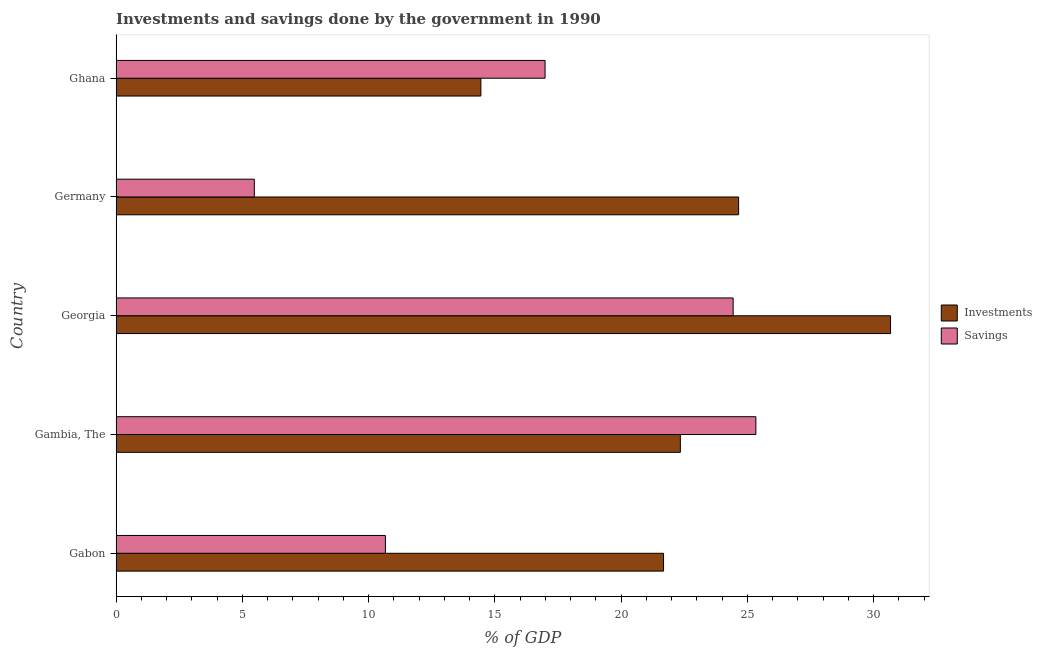How many groups of bars are there?
Provide a short and direct response. 5. Are the number of bars per tick equal to the number of legend labels?
Make the answer very short. Yes. How many bars are there on the 5th tick from the top?
Provide a succinct answer. 2. What is the label of the 2nd group of bars from the top?
Offer a very short reply. Germany. What is the savings of government in Germany?
Your answer should be compact. 5.47. Across all countries, what is the maximum investments of government?
Provide a short and direct response. 30.67. Across all countries, what is the minimum savings of government?
Offer a terse response. 5.47. In which country was the investments of government maximum?
Your answer should be very brief. Georgia. In which country was the savings of government minimum?
Offer a very short reply. Germany. What is the total savings of government in the graph?
Offer a very short reply. 82.89. What is the difference between the savings of government in Gambia, The and that in Georgia?
Provide a short and direct response. 0.9. What is the difference between the investments of government in Ghana and the savings of government in Germany?
Provide a succinct answer. 8.97. What is the average investments of government per country?
Make the answer very short. 22.76. What is the difference between the savings of government and investments of government in Gambia, The?
Offer a terse response. 2.99. In how many countries, is the savings of government greater than 30 %?
Your response must be concise. 0. What is the ratio of the investments of government in Gabon to that in Georgia?
Give a very brief answer. 0.71. Is the investments of government in Gambia, The less than that in Ghana?
Your response must be concise. No. What is the difference between the highest and the second highest investments of government?
Provide a succinct answer. 6.02. What is the difference between the highest and the lowest savings of government?
Give a very brief answer. 19.86. What does the 2nd bar from the top in Ghana represents?
Make the answer very short. Investments. What does the 1st bar from the bottom in Ghana represents?
Your answer should be very brief. Investments. What is the difference between two consecutive major ticks on the X-axis?
Ensure brevity in your answer.  5. Where does the legend appear in the graph?
Your answer should be compact. Center right. What is the title of the graph?
Ensure brevity in your answer.  Investments and savings done by the government in 1990. What is the label or title of the X-axis?
Your answer should be compact. % of GDP. What is the % of GDP of Investments in Gabon?
Offer a very short reply. 21.68. What is the % of GDP in Savings in Gabon?
Your answer should be very brief. 10.66. What is the % of GDP in Investments in Gambia, The?
Provide a succinct answer. 22.34. What is the % of GDP in Savings in Gambia, The?
Ensure brevity in your answer.  25.33. What is the % of GDP in Investments in Georgia?
Provide a short and direct response. 30.67. What is the % of GDP of Savings in Georgia?
Keep it short and to the point. 24.43. What is the % of GDP of Investments in Germany?
Your answer should be compact. 24.65. What is the % of GDP of Savings in Germany?
Your response must be concise. 5.47. What is the % of GDP of Investments in Ghana?
Provide a short and direct response. 14.44. What is the % of GDP in Savings in Ghana?
Offer a terse response. 16.99. Across all countries, what is the maximum % of GDP of Investments?
Keep it short and to the point. 30.67. Across all countries, what is the maximum % of GDP of Savings?
Offer a terse response. 25.33. Across all countries, what is the minimum % of GDP of Investments?
Provide a short and direct response. 14.44. Across all countries, what is the minimum % of GDP in Savings?
Provide a short and direct response. 5.47. What is the total % of GDP of Investments in the graph?
Offer a terse response. 113.78. What is the total % of GDP of Savings in the graph?
Give a very brief answer. 82.89. What is the difference between the % of GDP of Investments in Gabon and that in Gambia, The?
Give a very brief answer. -0.67. What is the difference between the % of GDP of Savings in Gabon and that in Gambia, The?
Make the answer very short. -14.67. What is the difference between the % of GDP of Investments in Gabon and that in Georgia?
Provide a succinct answer. -8.99. What is the difference between the % of GDP of Savings in Gabon and that in Georgia?
Make the answer very short. -13.77. What is the difference between the % of GDP of Investments in Gabon and that in Germany?
Offer a very short reply. -2.97. What is the difference between the % of GDP of Savings in Gabon and that in Germany?
Provide a short and direct response. 5.19. What is the difference between the % of GDP in Investments in Gabon and that in Ghana?
Ensure brevity in your answer.  7.23. What is the difference between the % of GDP in Savings in Gabon and that in Ghana?
Make the answer very short. -6.32. What is the difference between the % of GDP of Investments in Gambia, The and that in Georgia?
Ensure brevity in your answer.  -8.32. What is the difference between the % of GDP in Savings in Gambia, The and that in Georgia?
Ensure brevity in your answer.  0.9. What is the difference between the % of GDP of Investments in Gambia, The and that in Germany?
Provide a short and direct response. -2.31. What is the difference between the % of GDP in Savings in Gambia, The and that in Germany?
Give a very brief answer. 19.86. What is the difference between the % of GDP in Investments in Gambia, The and that in Ghana?
Provide a succinct answer. 7.9. What is the difference between the % of GDP in Savings in Gambia, The and that in Ghana?
Ensure brevity in your answer.  8.35. What is the difference between the % of GDP in Investments in Georgia and that in Germany?
Your answer should be compact. 6.02. What is the difference between the % of GDP of Savings in Georgia and that in Germany?
Provide a short and direct response. 18.96. What is the difference between the % of GDP in Investments in Georgia and that in Ghana?
Offer a very short reply. 16.22. What is the difference between the % of GDP in Savings in Georgia and that in Ghana?
Your answer should be compact. 7.45. What is the difference between the % of GDP in Investments in Germany and that in Ghana?
Provide a short and direct response. 10.21. What is the difference between the % of GDP of Savings in Germany and that in Ghana?
Ensure brevity in your answer.  -11.51. What is the difference between the % of GDP in Investments in Gabon and the % of GDP in Savings in Gambia, The?
Ensure brevity in your answer.  -3.66. What is the difference between the % of GDP in Investments in Gabon and the % of GDP in Savings in Georgia?
Make the answer very short. -2.76. What is the difference between the % of GDP in Investments in Gabon and the % of GDP in Savings in Germany?
Provide a succinct answer. 16.21. What is the difference between the % of GDP in Investments in Gabon and the % of GDP in Savings in Ghana?
Provide a short and direct response. 4.69. What is the difference between the % of GDP in Investments in Gambia, The and the % of GDP in Savings in Georgia?
Your answer should be compact. -2.09. What is the difference between the % of GDP in Investments in Gambia, The and the % of GDP in Savings in Germany?
Provide a short and direct response. 16.87. What is the difference between the % of GDP in Investments in Gambia, The and the % of GDP in Savings in Ghana?
Give a very brief answer. 5.36. What is the difference between the % of GDP of Investments in Georgia and the % of GDP of Savings in Germany?
Your response must be concise. 25.2. What is the difference between the % of GDP of Investments in Georgia and the % of GDP of Savings in Ghana?
Provide a succinct answer. 13.68. What is the difference between the % of GDP of Investments in Germany and the % of GDP of Savings in Ghana?
Offer a terse response. 7.67. What is the average % of GDP of Investments per country?
Make the answer very short. 22.76. What is the average % of GDP in Savings per country?
Ensure brevity in your answer.  16.58. What is the difference between the % of GDP of Investments and % of GDP of Savings in Gabon?
Your response must be concise. 11.01. What is the difference between the % of GDP in Investments and % of GDP in Savings in Gambia, The?
Provide a succinct answer. -2.99. What is the difference between the % of GDP in Investments and % of GDP in Savings in Georgia?
Your answer should be compact. 6.23. What is the difference between the % of GDP in Investments and % of GDP in Savings in Germany?
Your answer should be very brief. 19.18. What is the difference between the % of GDP of Investments and % of GDP of Savings in Ghana?
Provide a short and direct response. -2.54. What is the ratio of the % of GDP of Investments in Gabon to that in Gambia, The?
Ensure brevity in your answer.  0.97. What is the ratio of the % of GDP in Savings in Gabon to that in Gambia, The?
Make the answer very short. 0.42. What is the ratio of the % of GDP in Investments in Gabon to that in Georgia?
Provide a short and direct response. 0.71. What is the ratio of the % of GDP in Savings in Gabon to that in Georgia?
Your response must be concise. 0.44. What is the ratio of the % of GDP of Investments in Gabon to that in Germany?
Your answer should be compact. 0.88. What is the ratio of the % of GDP of Savings in Gabon to that in Germany?
Your answer should be very brief. 1.95. What is the ratio of the % of GDP of Investments in Gabon to that in Ghana?
Your answer should be very brief. 1.5. What is the ratio of the % of GDP in Savings in Gabon to that in Ghana?
Provide a short and direct response. 0.63. What is the ratio of the % of GDP of Investments in Gambia, The to that in Georgia?
Your answer should be very brief. 0.73. What is the ratio of the % of GDP in Savings in Gambia, The to that in Georgia?
Ensure brevity in your answer.  1.04. What is the ratio of the % of GDP of Investments in Gambia, The to that in Germany?
Offer a very short reply. 0.91. What is the ratio of the % of GDP of Savings in Gambia, The to that in Germany?
Offer a terse response. 4.63. What is the ratio of the % of GDP of Investments in Gambia, The to that in Ghana?
Offer a very short reply. 1.55. What is the ratio of the % of GDP of Savings in Gambia, The to that in Ghana?
Offer a terse response. 1.49. What is the ratio of the % of GDP of Investments in Georgia to that in Germany?
Provide a succinct answer. 1.24. What is the ratio of the % of GDP in Savings in Georgia to that in Germany?
Make the answer very short. 4.47. What is the ratio of the % of GDP in Investments in Georgia to that in Ghana?
Keep it short and to the point. 2.12. What is the ratio of the % of GDP in Savings in Georgia to that in Ghana?
Your answer should be compact. 1.44. What is the ratio of the % of GDP in Investments in Germany to that in Ghana?
Make the answer very short. 1.71. What is the ratio of the % of GDP in Savings in Germany to that in Ghana?
Provide a succinct answer. 0.32. What is the difference between the highest and the second highest % of GDP of Investments?
Provide a succinct answer. 6.02. What is the difference between the highest and the second highest % of GDP in Savings?
Offer a terse response. 0.9. What is the difference between the highest and the lowest % of GDP of Investments?
Give a very brief answer. 16.22. What is the difference between the highest and the lowest % of GDP in Savings?
Provide a succinct answer. 19.86. 